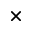<formula> <loc_0><loc_0><loc_500><loc_500>\times</formula> 